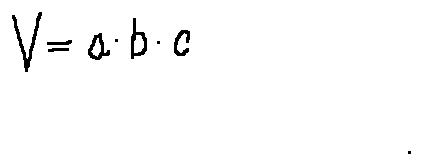<formula> <loc_0><loc_0><loc_500><loc_500>V = a \cdot b \cdot c</formula> 